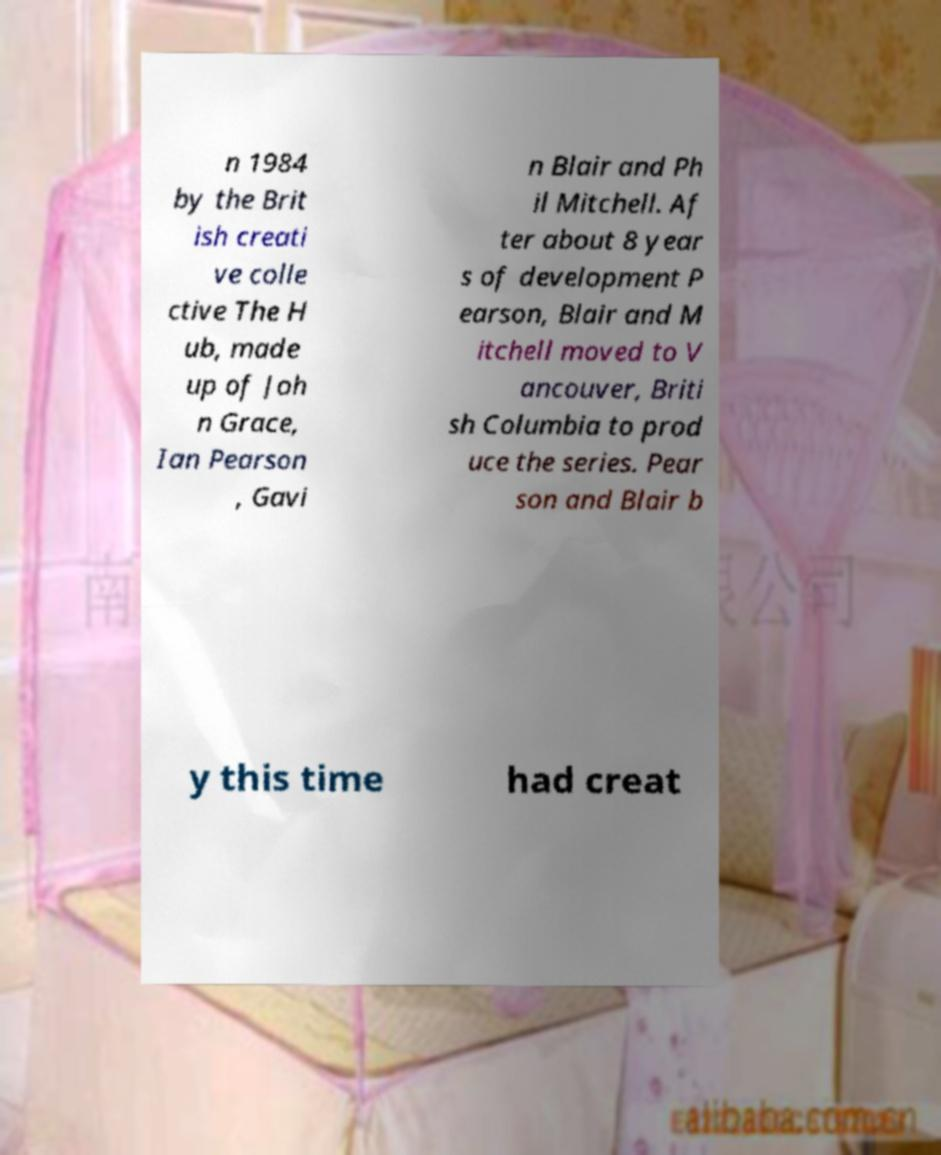Could you assist in decoding the text presented in this image and type it out clearly? n 1984 by the Brit ish creati ve colle ctive The H ub, made up of Joh n Grace, Ian Pearson , Gavi n Blair and Ph il Mitchell. Af ter about 8 year s of development P earson, Blair and M itchell moved to V ancouver, Briti sh Columbia to prod uce the series. Pear son and Blair b y this time had creat 